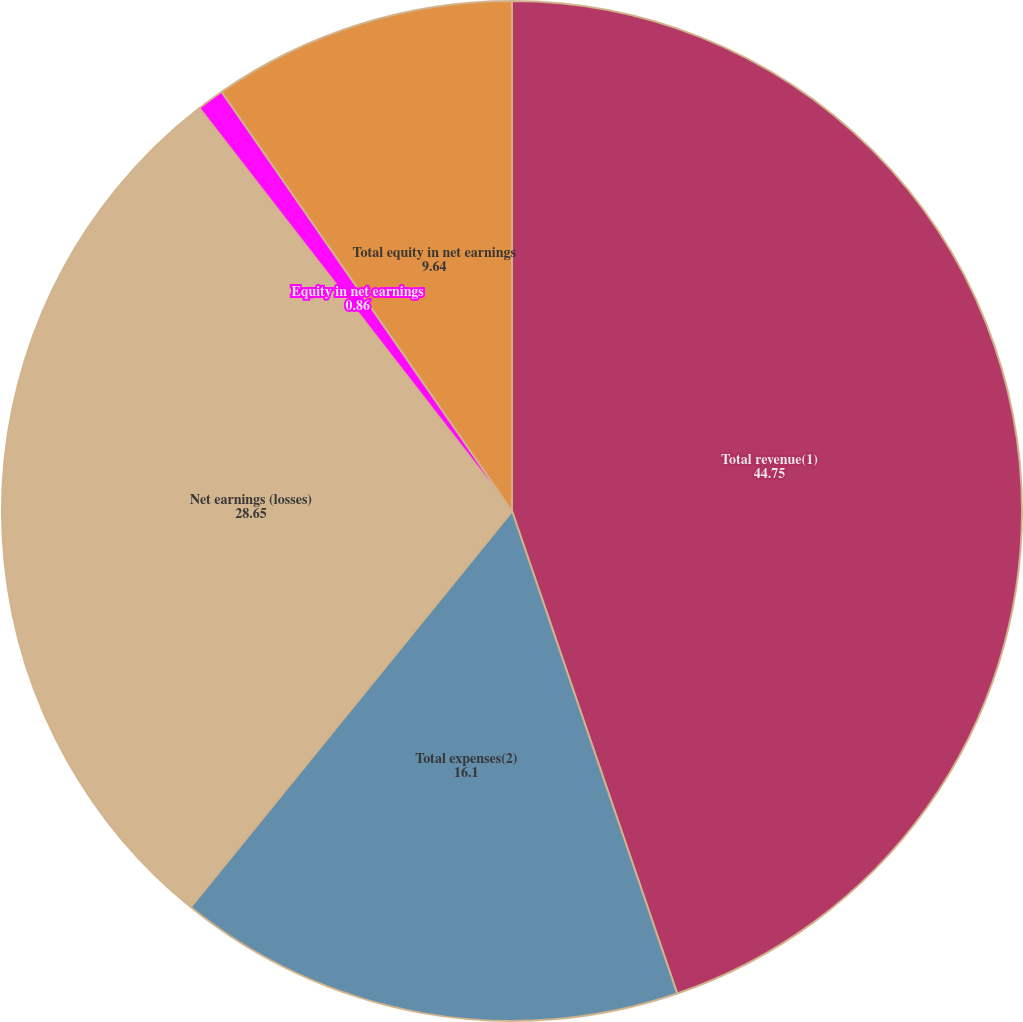Convert chart. <chart><loc_0><loc_0><loc_500><loc_500><pie_chart><fcel>Total revenue(1)<fcel>Total expenses(2)<fcel>Net earnings (losses)<fcel>Equity in net earnings<fcel>Total equity in net earnings<nl><fcel>44.75%<fcel>16.1%<fcel>28.65%<fcel>0.86%<fcel>9.64%<nl></chart> 